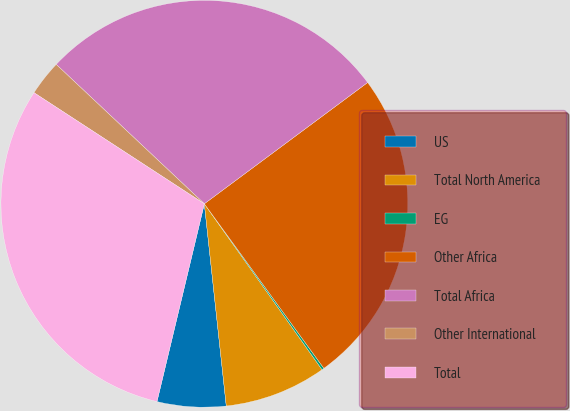<chart> <loc_0><loc_0><loc_500><loc_500><pie_chart><fcel>US<fcel>Total North America<fcel>EG<fcel>Other Africa<fcel>Total Africa<fcel>Other International<fcel>Total<nl><fcel>5.46%<fcel>8.1%<fcel>0.18%<fcel>25.17%<fcel>27.82%<fcel>2.82%<fcel>30.46%<nl></chart> 